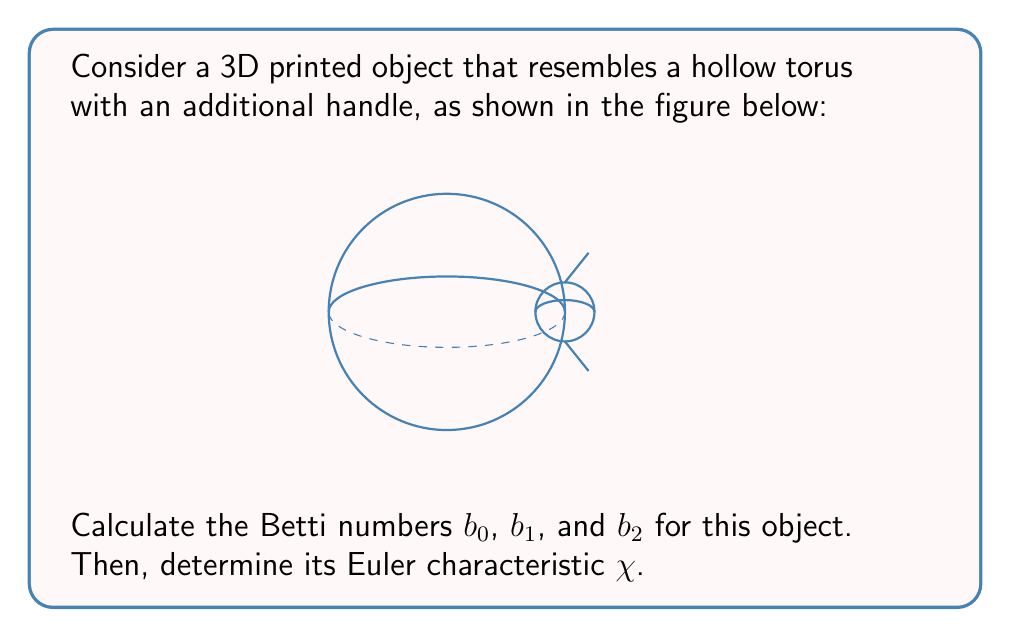Solve this math problem. To solve this problem, we'll follow these steps:

1) First, let's understand what the Betti numbers represent:
   - $b_0$: number of connected components
   - $b_1$: number of 1-dimensional holes (loops)
   - $b_2$: number of 2-dimensional holes (voids)

2) Analyzing the object:
   - It's a single connected component, so $b_0 = 1$
   - It has two 1-dimensional holes: the main hole of the torus and the hole created by the handle, so $b_1 = 2$
   - It has one 2-dimensional hole (the void inside the torus), so $b_2 = 1$

3) The Euler characteristic $\chi$ is related to the Betti numbers by the formula:

   $$\chi = b_0 - b_1 + b_2$$

4) Substituting the values we found:

   $$\chi = 1 - 2 + 1 = 0$$

This result is consistent with the fact that the Euler characteristic of a torus with a handle (also known as a 2-hole torus or double torus) is indeed 0.

5) We can verify this result using the general formula for the Euler characteristic of a g-hole torus:

   $$\chi = 2 - 2g$$

   where g is the genus (number of handles). In this case, g = 2, so:

   $$\chi = 2 - 2(2) = 2 - 4 = 0$$

   This confirms our calculation using Betti numbers.
Answer: $b_0 = 1$, $b_1 = 2$, $b_2 = 1$, $\chi = 0$ 